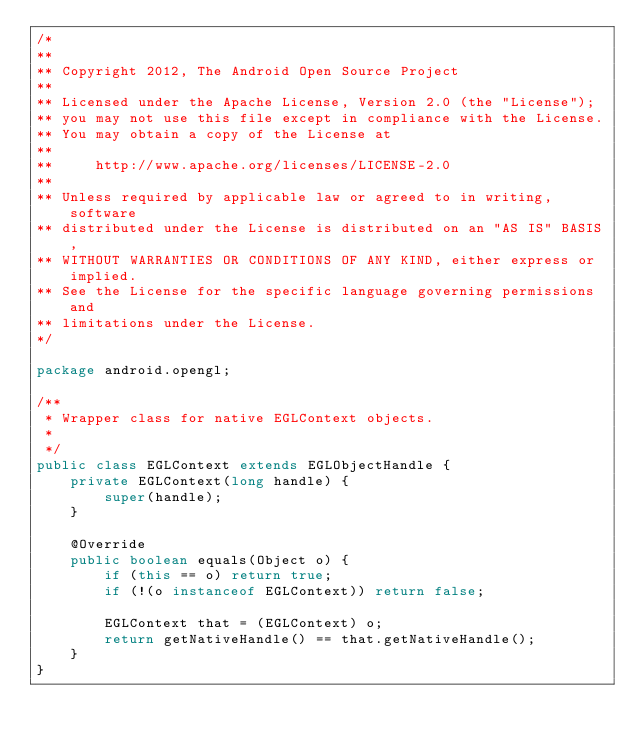Convert code to text. <code><loc_0><loc_0><loc_500><loc_500><_Java_>/*
**
** Copyright 2012, The Android Open Source Project
**
** Licensed under the Apache License, Version 2.0 (the "License");
** you may not use this file except in compliance with the License.
** You may obtain a copy of the License at
**
**     http://www.apache.org/licenses/LICENSE-2.0
**
** Unless required by applicable law or agreed to in writing, software
** distributed under the License is distributed on an "AS IS" BASIS,
** WITHOUT WARRANTIES OR CONDITIONS OF ANY KIND, either express or implied.
** See the License for the specific language governing permissions and
** limitations under the License.
*/

package android.opengl;

/**
 * Wrapper class for native EGLContext objects.
 *
 */
public class EGLContext extends EGLObjectHandle {
    private EGLContext(long handle) {
        super(handle);
    }

    @Override
    public boolean equals(Object o) {
        if (this == o) return true;
        if (!(o instanceof EGLContext)) return false;

        EGLContext that = (EGLContext) o;
        return getNativeHandle() == that.getNativeHandle();
    }
}
</code> 